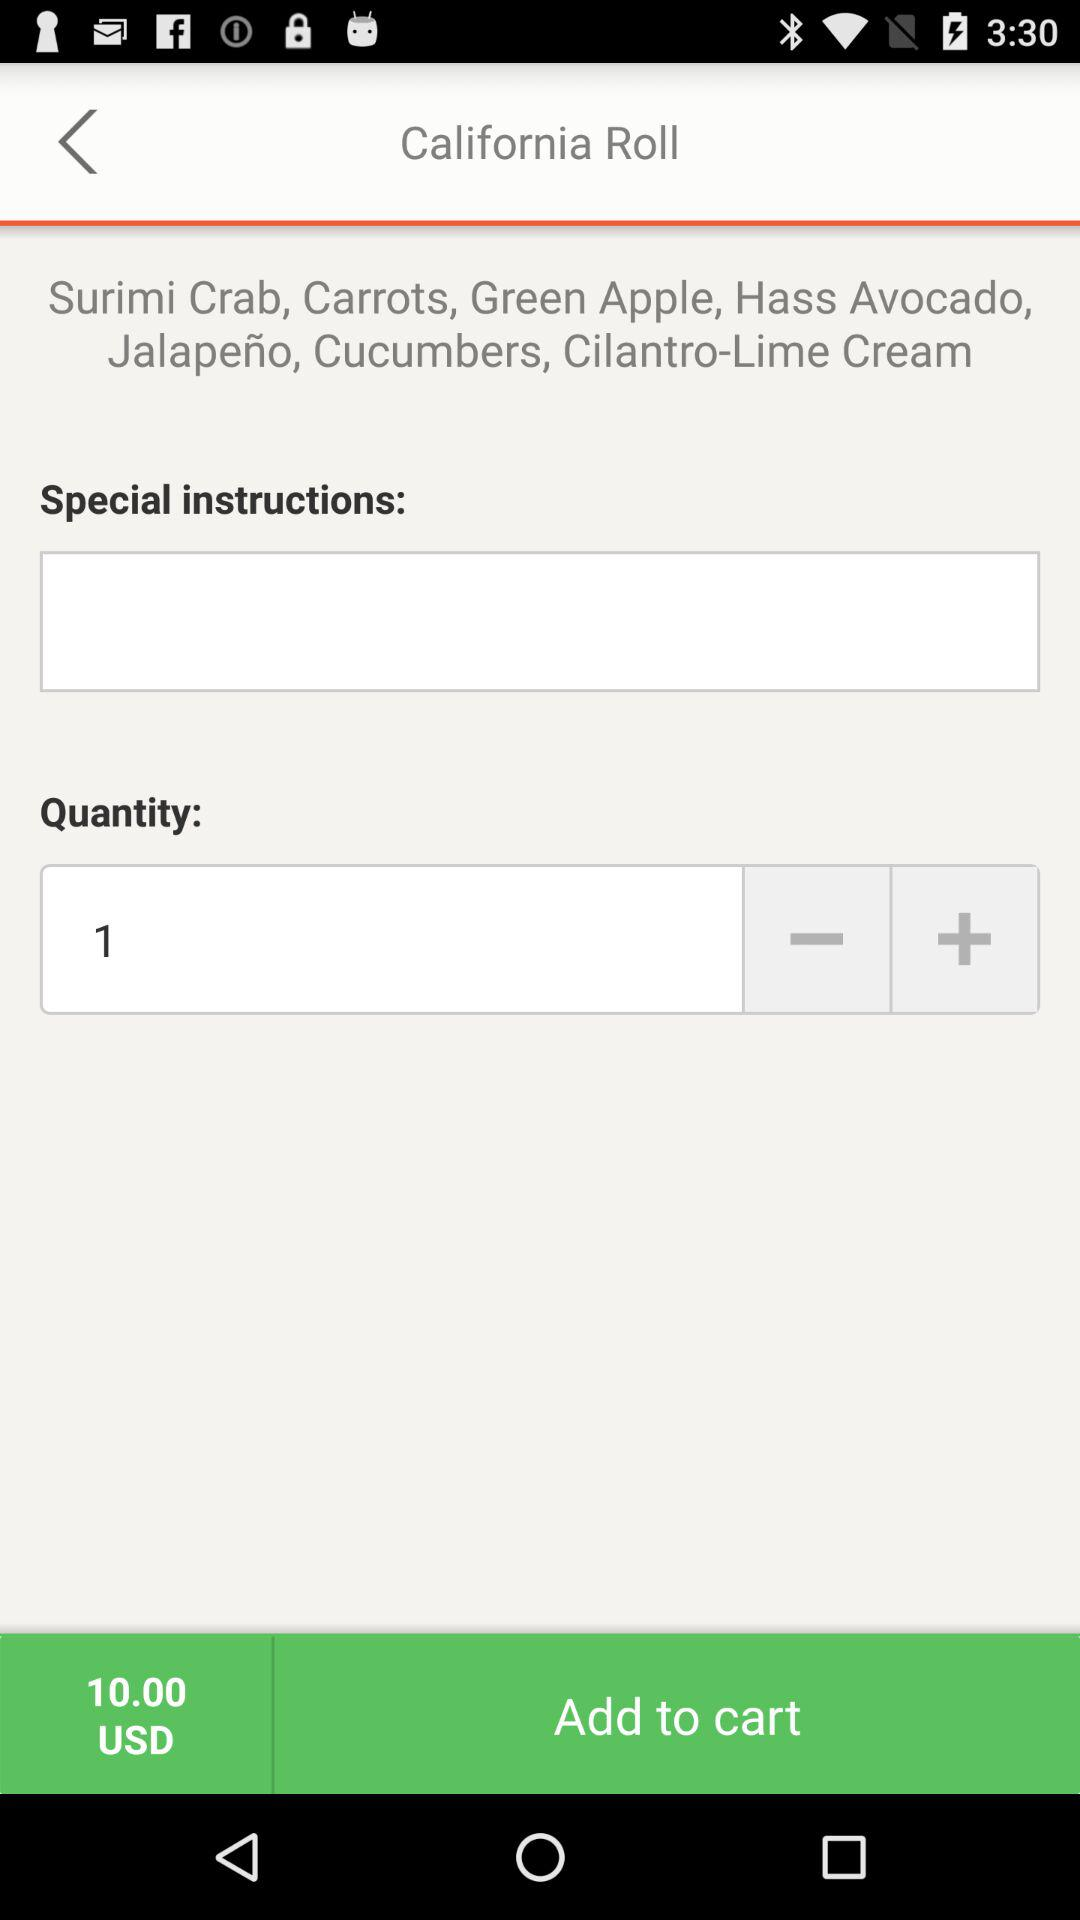How many ingredients are in the California Roll?
Answer the question using a single word or phrase. 7 